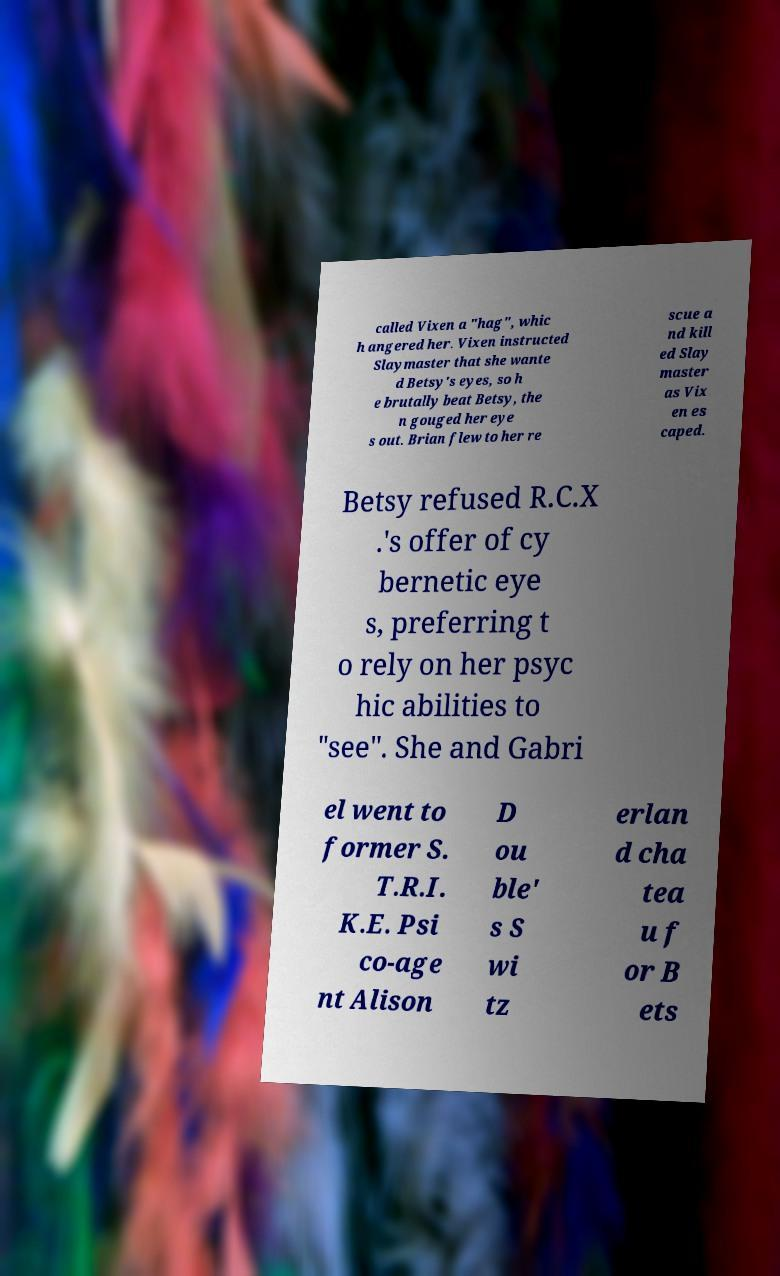There's text embedded in this image that I need extracted. Can you transcribe it verbatim? called Vixen a "hag", whic h angered her. Vixen instructed Slaymaster that she wante d Betsy's eyes, so h e brutally beat Betsy, the n gouged her eye s out. Brian flew to her re scue a nd kill ed Slay master as Vix en es caped. Betsy refused R.C.X .'s offer of cy bernetic eye s, preferring t o rely on her psyc hic abilities to "see". She and Gabri el went to former S. T.R.I. K.E. Psi co-age nt Alison D ou ble' s S wi tz erlan d cha tea u f or B ets 